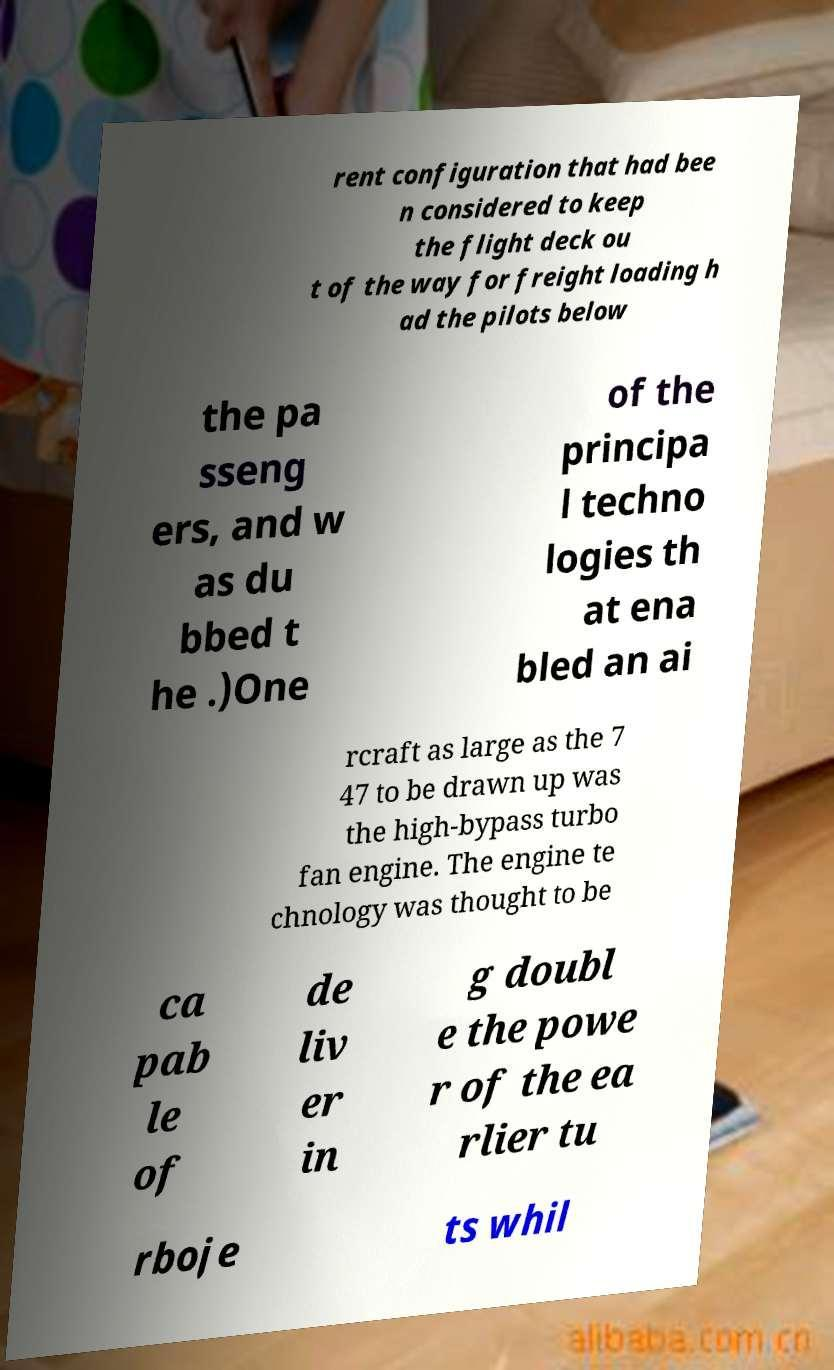There's text embedded in this image that I need extracted. Can you transcribe it verbatim? rent configuration that had bee n considered to keep the flight deck ou t of the way for freight loading h ad the pilots below the pa sseng ers, and w as du bbed t he .)One of the principa l techno logies th at ena bled an ai rcraft as large as the 7 47 to be drawn up was the high-bypass turbo fan engine. The engine te chnology was thought to be ca pab le of de liv er in g doubl e the powe r of the ea rlier tu rboje ts whil 